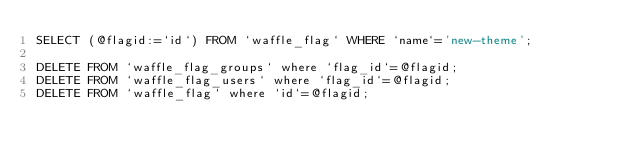Convert code to text. <code><loc_0><loc_0><loc_500><loc_500><_SQL_>SELECT (@flagid:=`id`) FROM `waffle_flag` WHERE `name`='new-theme';

DELETE FROM `waffle_flag_groups` where `flag_id`=@flagid;
DELETE FROM `waffle_flag_users` where `flag_id`=@flagid;
DELETE FROM `waffle_flag` where `id`=@flagid;
</code> 